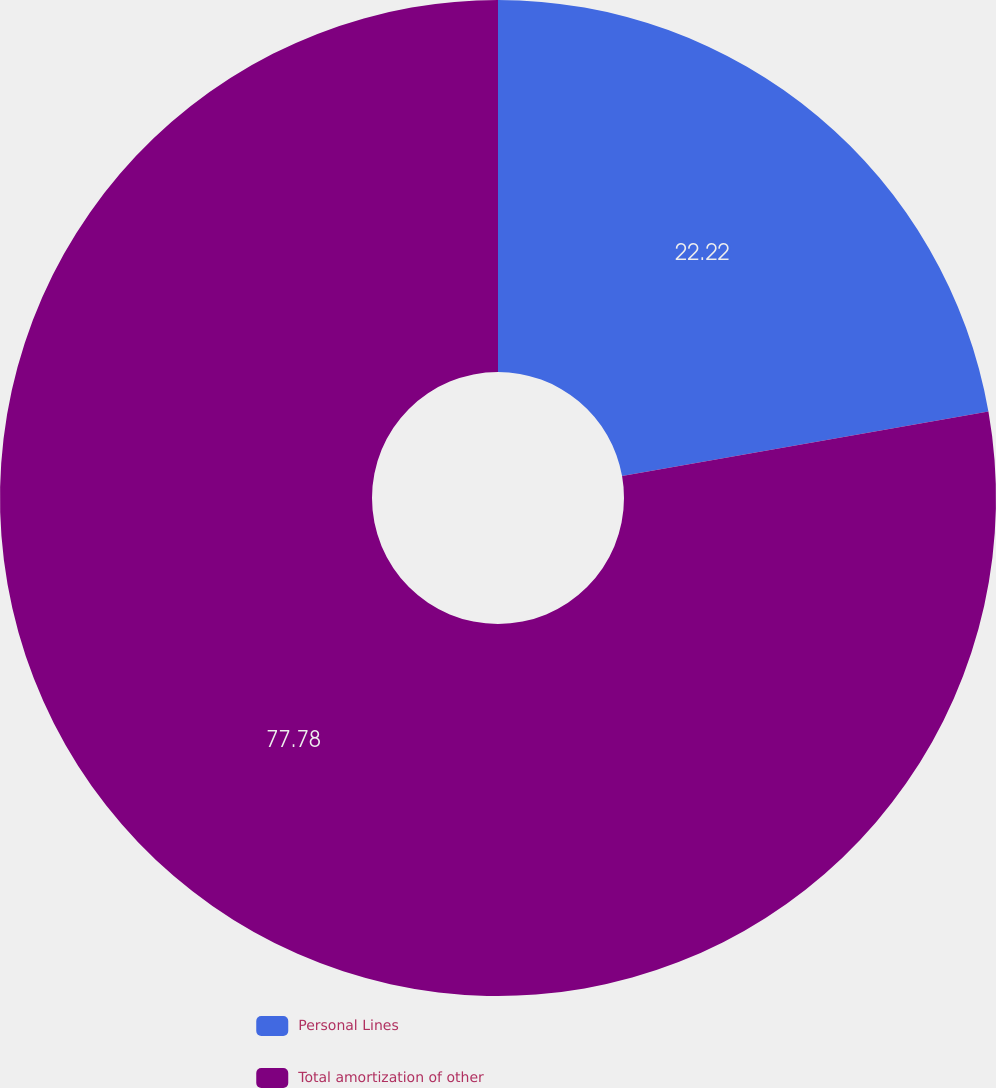<chart> <loc_0><loc_0><loc_500><loc_500><pie_chart><fcel>Personal Lines<fcel>Total amortization of other<nl><fcel>22.22%<fcel>77.78%<nl></chart> 